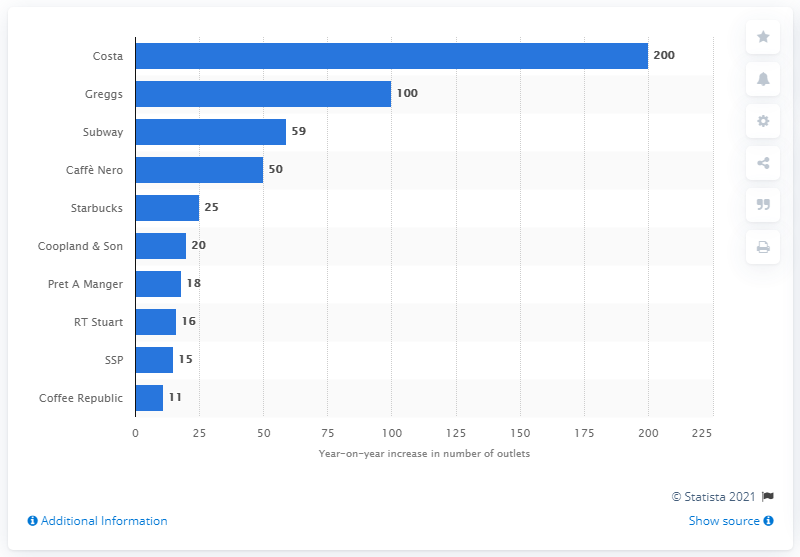Draw attention to some important aspects in this diagram. In 2013, Costa had approximately 200 new outlets opened. Greggs is the second fastest-growing bakery retailer in the United Kingdom. 